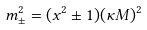<formula> <loc_0><loc_0><loc_500><loc_500>m ^ { 2 } _ { \pm } = ( x ^ { 2 } \pm 1 ) ( \kappa M ) ^ { 2 }</formula> 